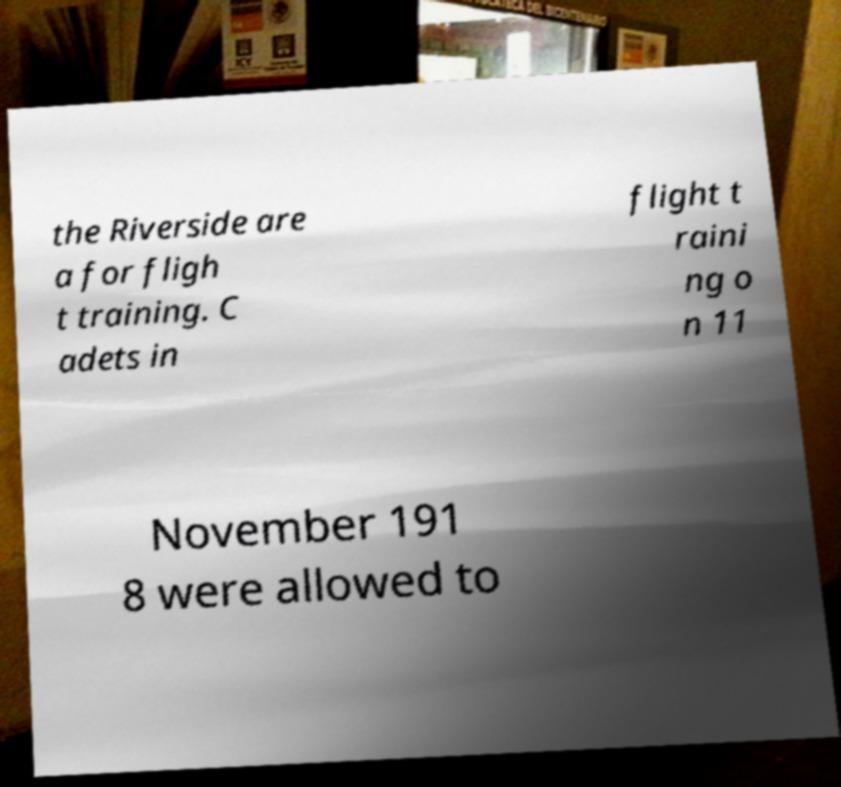There's text embedded in this image that I need extracted. Can you transcribe it verbatim? the Riverside are a for fligh t training. C adets in flight t raini ng o n 11 November 191 8 were allowed to 